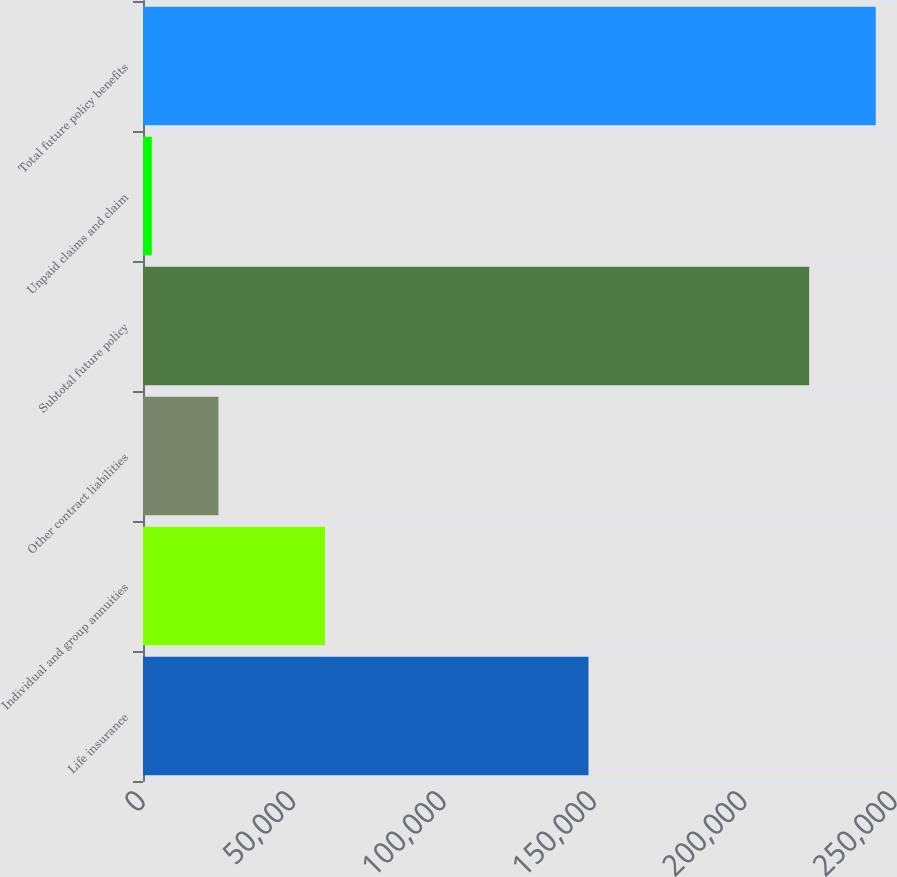<chart> <loc_0><loc_0><loc_500><loc_500><bar_chart><fcel>Life insurance<fcel>Individual and group annuities<fcel>Other contract liabilities<fcel>Subtotal future policy<fcel>Unpaid claims and claim<fcel>Total future policy benefits<nl><fcel>148100<fcel>60493<fcel>25065.5<fcel>221465<fcel>2919<fcel>243612<nl></chart> 